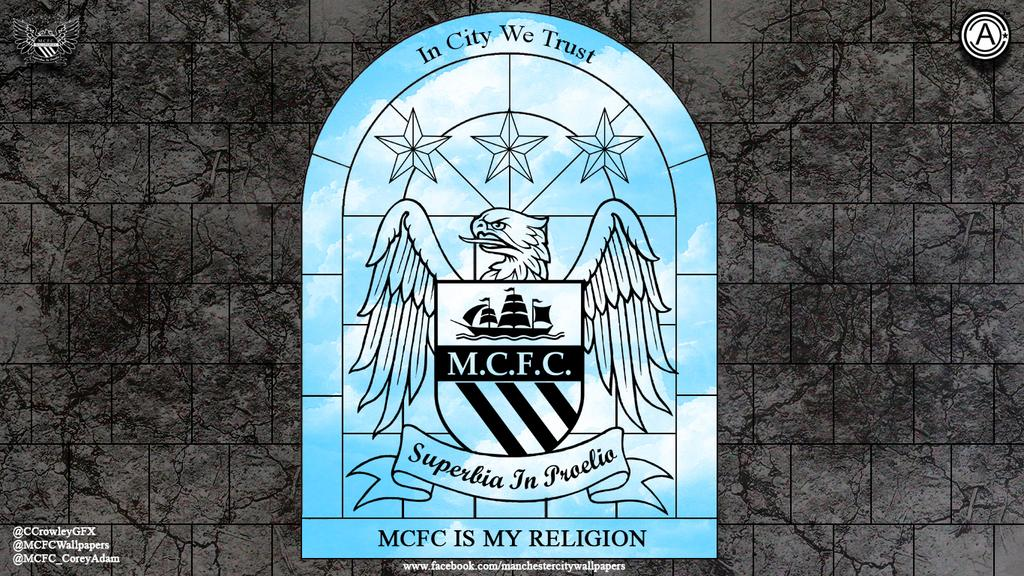<image>
Offer a succinct explanation of the picture presented. An illustration of a window is labeled MCFC is my religion. 